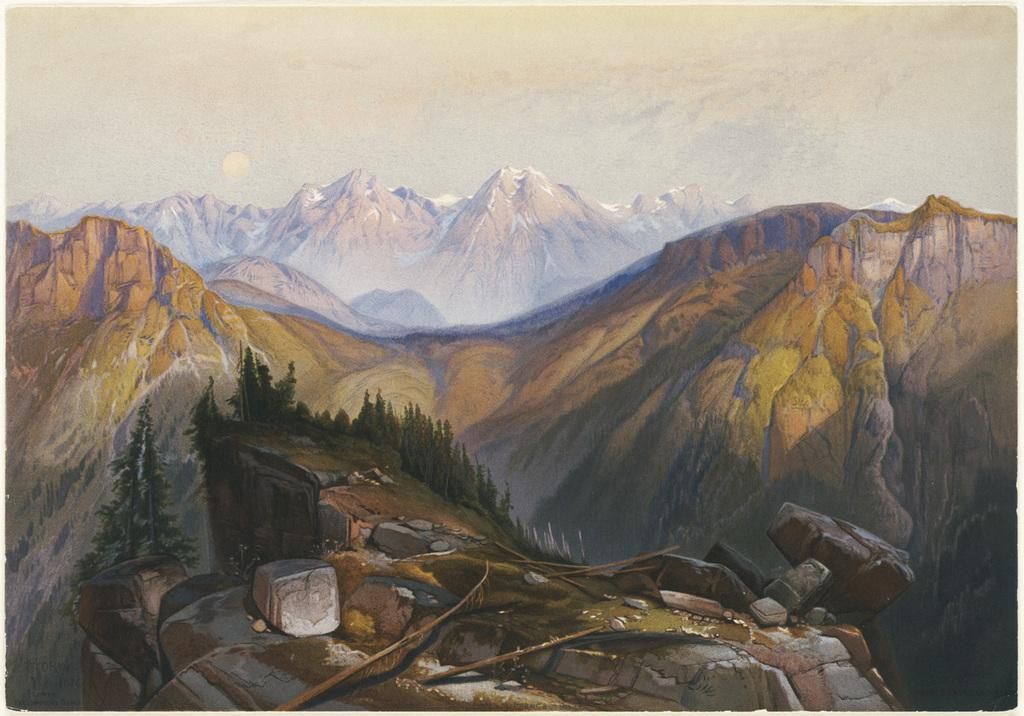What type of natural formation can be seen in the image? There are mountains in the image. What can be found on the mountains? There are trees, rocks, and sticks on the mountains. What is visible in the background of the image? The sky is visible in the background of the image. What type of yam can be seen growing on the mountains in the image? There are no yams present in the image; the image features mountains with trees, rocks, and sticks. 